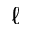<formula> <loc_0><loc_0><loc_500><loc_500>\ell</formula> 